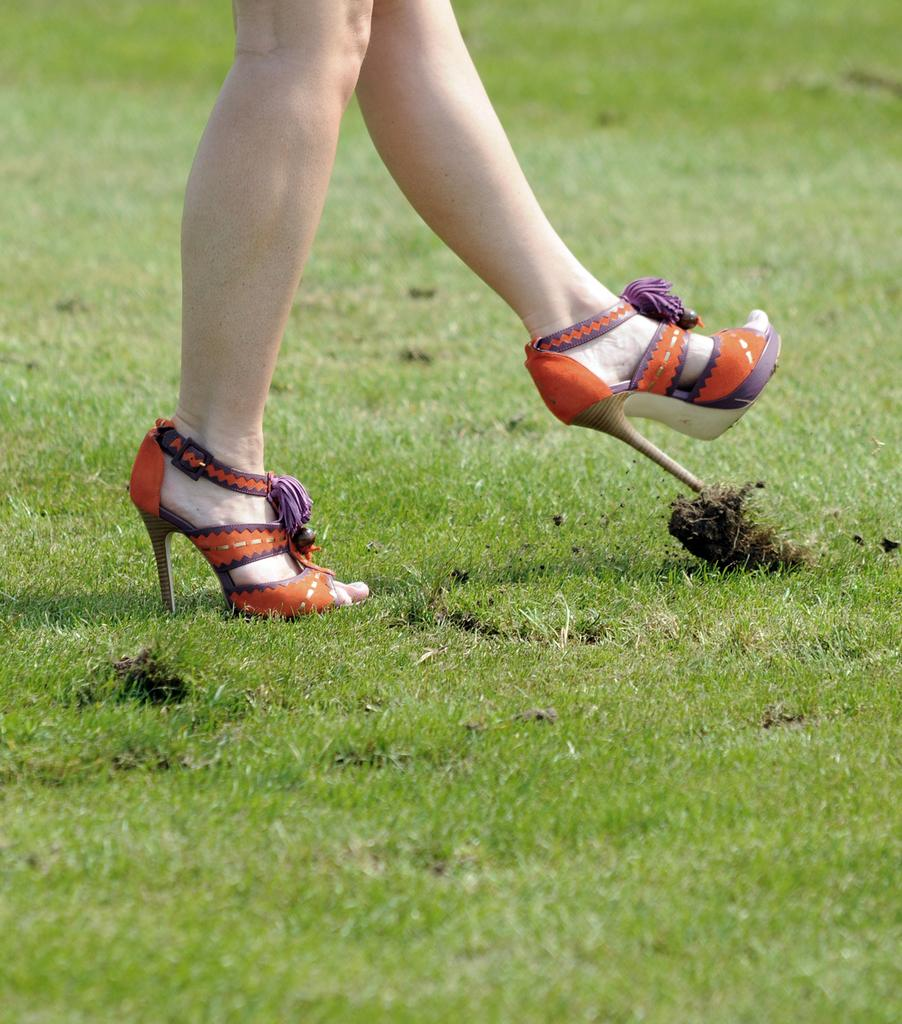What part of a woman's body is visible in the image? There is a woman's leg in the image. What type of footwear is the woman wearing? The woman is wearing orange-colored sandals. What type of vegetation is visible at the bottom of the image? Green grass is visible at the bottom of the image. How many goats are present in the image? There are no goats present in the image. What time of day is it in the image? The time of day cannot be determined from the image. 